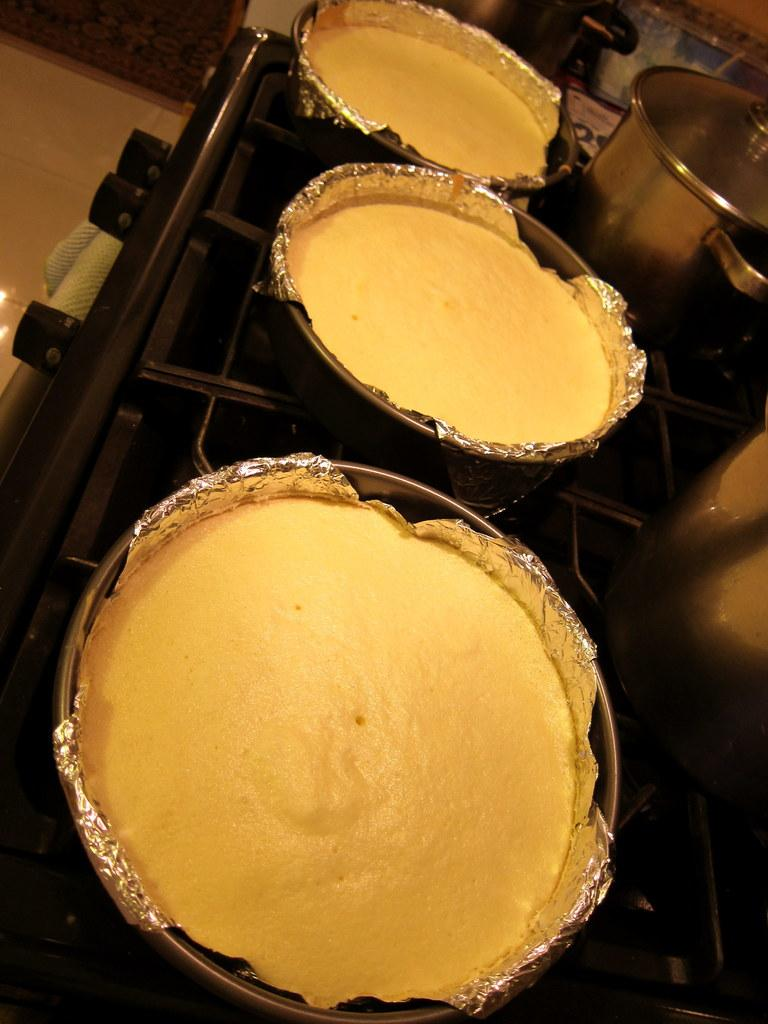What type of food items can be seen in the image? There are food items in bowls in the image. What cooking equipment is visible in the image? There are cooking pots with lids in the image. What financial advice can be given by the expert in the image? There is no expert present in the image, and therefore no financial advice can be given. What position does the person holding the money in the image have? There is no person holding money in the image. 